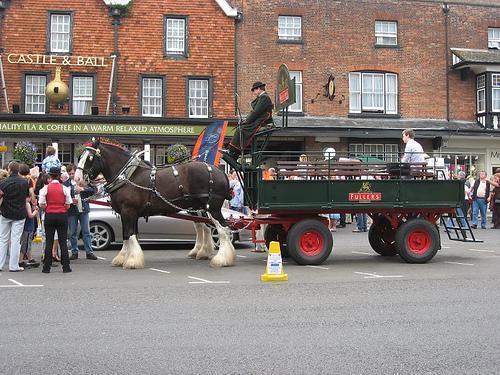How many red rims are on the wheels?
Give a very brief answer. 2. How many horses are there?
Give a very brief answer. 1. How many people can be seen?
Give a very brief answer. 2. 